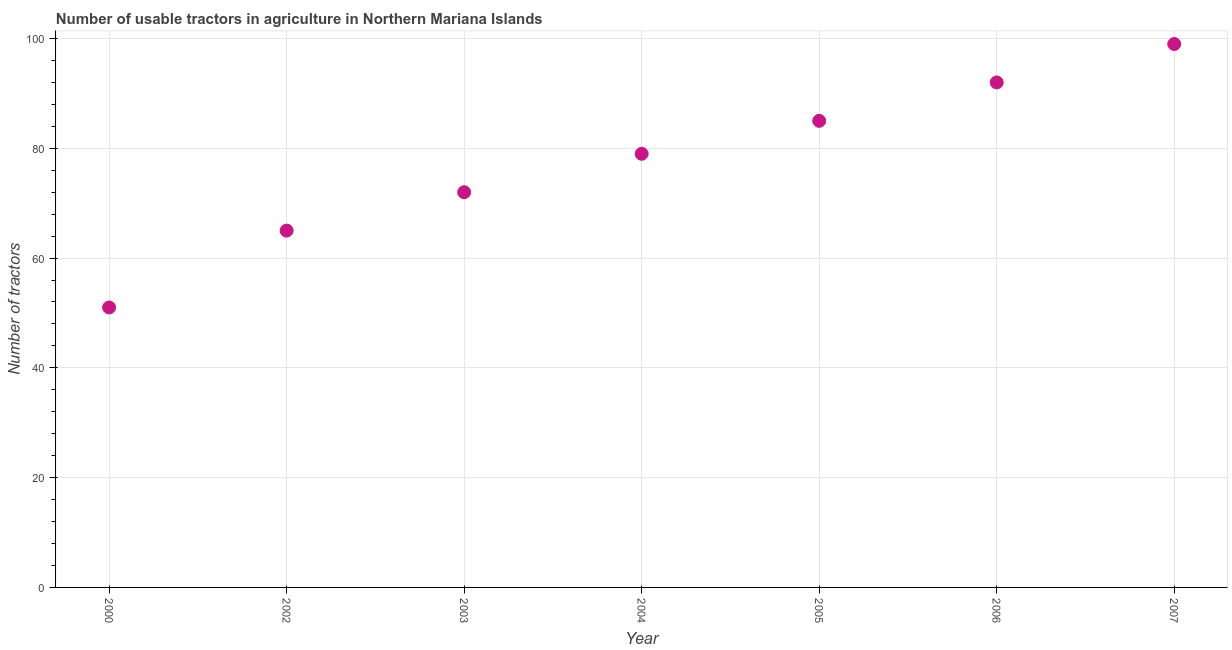What is the number of tractors in 2006?
Make the answer very short. 92. Across all years, what is the maximum number of tractors?
Give a very brief answer. 99. Across all years, what is the minimum number of tractors?
Provide a succinct answer. 51. What is the sum of the number of tractors?
Make the answer very short. 543. What is the difference between the number of tractors in 2004 and 2005?
Your response must be concise. -6. What is the average number of tractors per year?
Offer a terse response. 77.57. What is the median number of tractors?
Provide a short and direct response. 79. Do a majority of the years between 2004 and 2002 (inclusive) have number of tractors greater than 20 ?
Your answer should be very brief. No. What is the ratio of the number of tractors in 2000 to that in 2004?
Offer a terse response. 0.65. What is the difference between the highest and the second highest number of tractors?
Give a very brief answer. 7. What is the difference between the highest and the lowest number of tractors?
Provide a short and direct response. 48. In how many years, is the number of tractors greater than the average number of tractors taken over all years?
Keep it short and to the point. 4. Does the number of tractors monotonically increase over the years?
Your answer should be very brief. Yes. How many years are there in the graph?
Your answer should be very brief. 7. Are the values on the major ticks of Y-axis written in scientific E-notation?
Your response must be concise. No. Does the graph contain any zero values?
Your answer should be compact. No. Does the graph contain grids?
Offer a very short reply. Yes. What is the title of the graph?
Your answer should be very brief. Number of usable tractors in agriculture in Northern Mariana Islands. What is the label or title of the Y-axis?
Offer a terse response. Number of tractors. What is the Number of tractors in 2000?
Offer a terse response. 51. What is the Number of tractors in 2003?
Your answer should be very brief. 72. What is the Number of tractors in 2004?
Offer a terse response. 79. What is the Number of tractors in 2006?
Your answer should be compact. 92. What is the Number of tractors in 2007?
Give a very brief answer. 99. What is the difference between the Number of tractors in 2000 and 2002?
Make the answer very short. -14. What is the difference between the Number of tractors in 2000 and 2003?
Offer a terse response. -21. What is the difference between the Number of tractors in 2000 and 2005?
Keep it short and to the point. -34. What is the difference between the Number of tractors in 2000 and 2006?
Make the answer very short. -41. What is the difference between the Number of tractors in 2000 and 2007?
Provide a succinct answer. -48. What is the difference between the Number of tractors in 2002 and 2003?
Ensure brevity in your answer.  -7. What is the difference between the Number of tractors in 2002 and 2004?
Give a very brief answer. -14. What is the difference between the Number of tractors in 2002 and 2006?
Give a very brief answer. -27. What is the difference between the Number of tractors in 2002 and 2007?
Give a very brief answer. -34. What is the difference between the Number of tractors in 2003 and 2004?
Make the answer very short. -7. What is the difference between the Number of tractors in 2003 and 2005?
Provide a succinct answer. -13. What is the difference between the Number of tractors in 2003 and 2007?
Your answer should be compact. -27. What is the difference between the Number of tractors in 2005 and 2006?
Offer a very short reply. -7. What is the difference between the Number of tractors in 2005 and 2007?
Offer a terse response. -14. What is the difference between the Number of tractors in 2006 and 2007?
Offer a very short reply. -7. What is the ratio of the Number of tractors in 2000 to that in 2002?
Make the answer very short. 0.79. What is the ratio of the Number of tractors in 2000 to that in 2003?
Your response must be concise. 0.71. What is the ratio of the Number of tractors in 2000 to that in 2004?
Ensure brevity in your answer.  0.65. What is the ratio of the Number of tractors in 2000 to that in 2005?
Provide a succinct answer. 0.6. What is the ratio of the Number of tractors in 2000 to that in 2006?
Your answer should be very brief. 0.55. What is the ratio of the Number of tractors in 2000 to that in 2007?
Your answer should be very brief. 0.52. What is the ratio of the Number of tractors in 2002 to that in 2003?
Provide a succinct answer. 0.9. What is the ratio of the Number of tractors in 2002 to that in 2004?
Your answer should be compact. 0.82. What is the ratio of the Number of tractors in 2002 to that in 2005?
Give a very brief answer. 0.77. What is the ratio of the Number of tractors in 2002 to that in 2006?
Your response must be concise. 0.71. What is the ratio of the Number of tractors in 2002 to that in 2007?
Your answer should be compact. 0.66. What is the ratio of the Number of tractors in 2003 to that in 2004?
Ensure brevity in your answer.  0.91. What is the ratio of the Number of tractors in 2003 to that in 2005?
Offer a terse response. 0.85. What is the ratio of the Number of tractors in 2003 to that in 2006?
Ensure brevity in your answer.  0.78. What is the ratio of the Number of tractors in 2003 to that in 2007?
Offer a terse response. 0.73. What is the ratio of the Number of tractors in 2004 to that in 2005?
Offer a very short reply. 0.93. What is the ratio of the Number of tractors in 2004 to that in 2006?
Offer a very short reply. 0.86. What is the ratio of the Number of tractors in 2004 to that in 2007?
Keep it short and to the point. 0.8. What is the ratio of the Number of tractors in 2005 to that in 2006?
Give a very brief answer. 0.92. What is the ratio of the Number of tractors in 2005 to that in 2007?
Your answer should be compact. 0.86. What is the ratio of the Number of tractors in 2006 to that in 2007?
Your response must be concise. 0.93. 